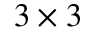<formula> <loc_0><loc_0><loc_500><loc_500>3 \times 3</formula> 